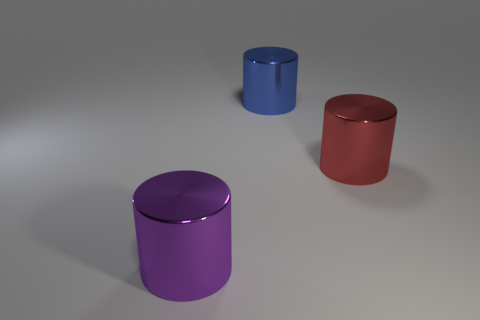Subtract all red cylinders. Subtract all brown balls. How many cylinders are left? 2 Add 3 large cyan cylinders. How many objects exist? 6 Add 2 purple cylinders. How many purple cylinders exist? 3 Subtract 0 yellow balls. How many objects are left? 3 Subtract all big shiny things. Subtract all small blue shiny cubes. How many objects are left? 0 Add 2 blue cylinders. How many blue cylinders are left? 3 